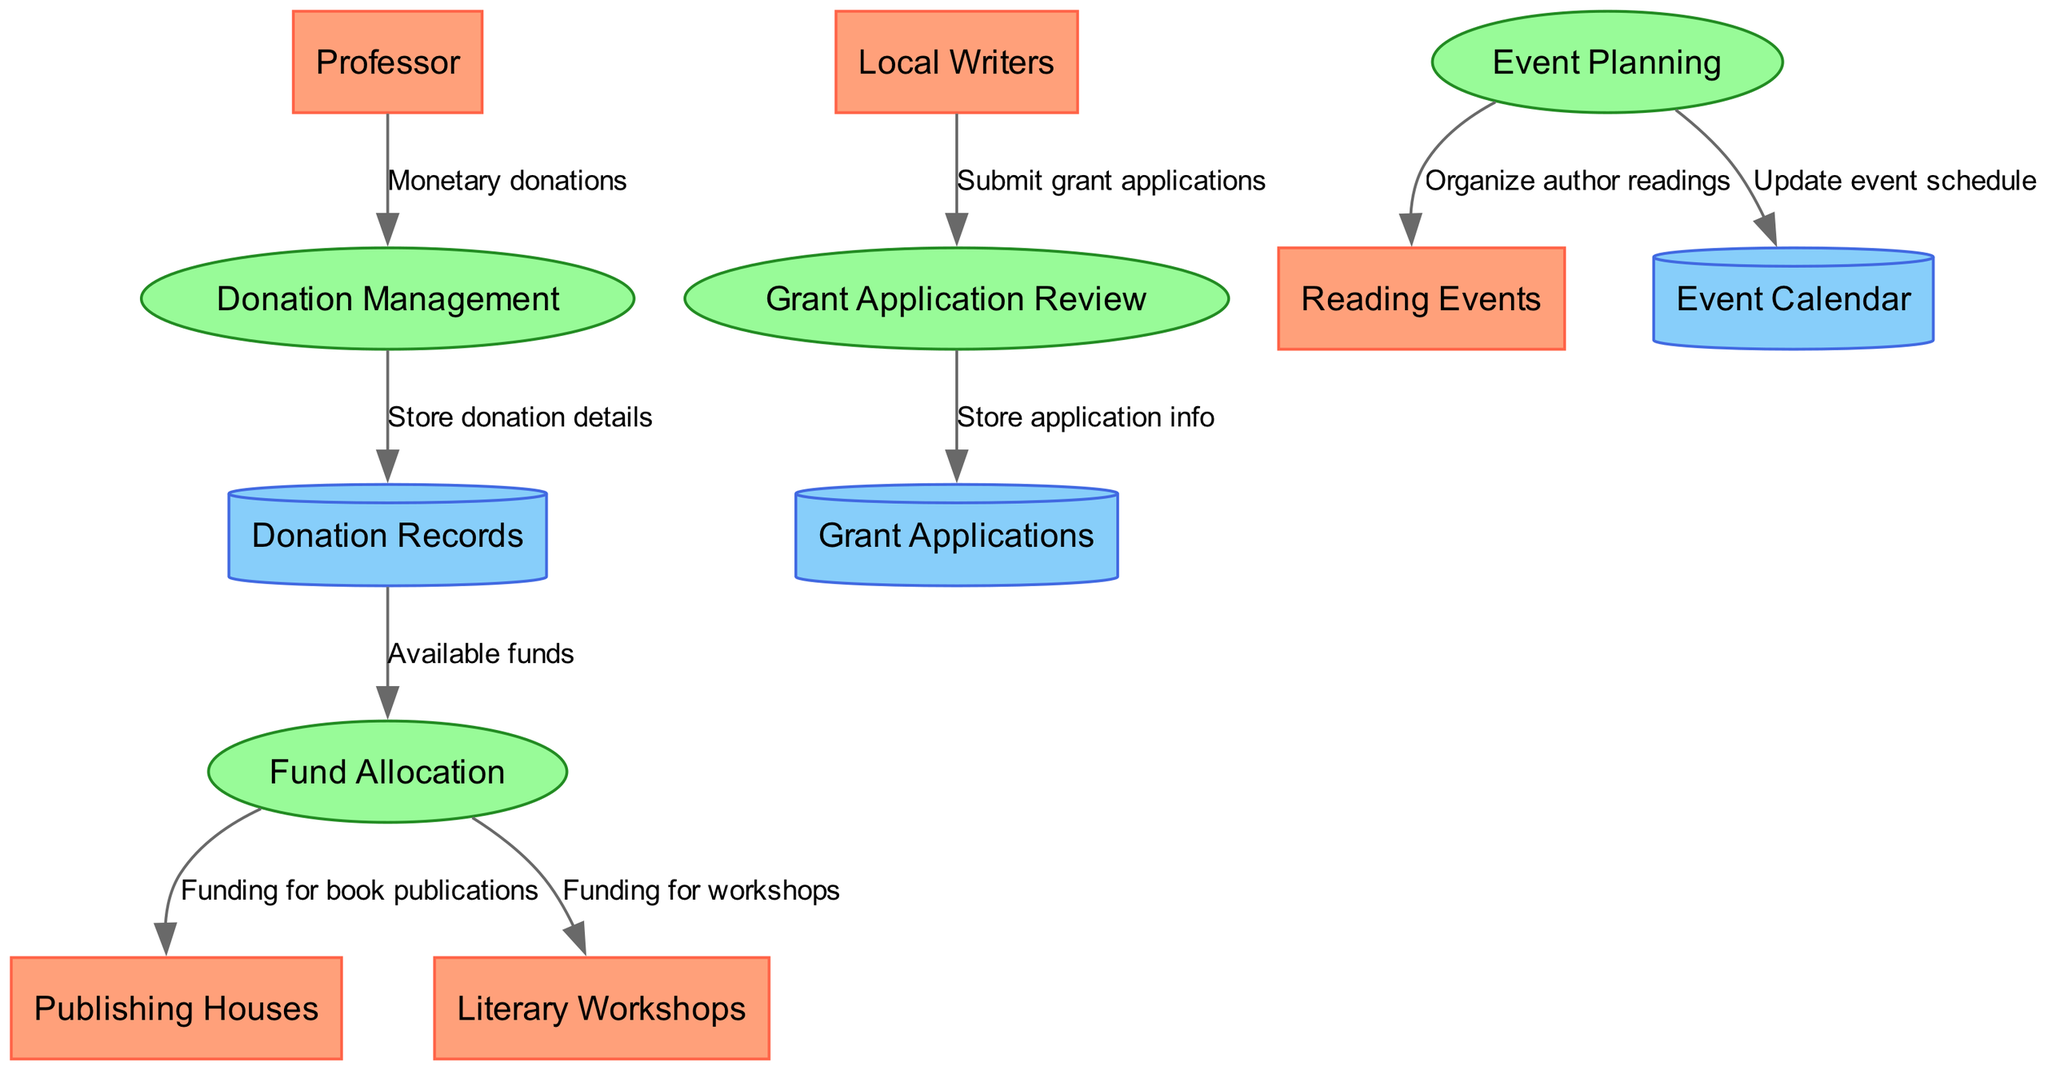What external entity initiates the donation process? The external entity that initiates the donation process, as shown in the diagram, is the "Professor". This is evident from the flow that starts from the "Professor" and goes to the "Donation Management" process, indicating that the professor is the source of monetary donations.
Answer: Professor How many processes are involved in fund allocation? In the diagram, there are three specific processes that are involved with fund allocation: "Donation Management", "Fund Allocation", and "Grant Application Review". Counting them gives us a total of three processes that are involved in managing and distributing the funds.
Answer: 3 What information does the "Donation Management" send to the "Donation Records"? The "Donation Management" process sends "Store donation details" to the "Donation Records". This is indicated in the flow from "Donation Management" to "Donation Records", indicating that donation details are stored as part of the record-keeping step.
Answer: Store donation details Which process is responsible for reviewing grant applications? The process that is responsible for reviewing grant applications is "Grant Application Review". This is clearly indicated in the diagram as the process that receives submissions from "Local Writers" in the form of grant applications.
Answer: Grant Application Review What are the two types of funding directed from "Fund Allocation"? The "Fund Allocation" process directs funding to "Publishing Houses" for book publications and to "Literary Workshops" for funding workshops. This dual pathway highlights the specific areas that receive financial support from the allocated funds.
Answer: Publishing Houses, Literary Workshops What entity receives updates about the organized events? The entity that receives updates about the organized events is the "Event Calendar". In the diagram, it shows the flow from "Event Planning" to "Event Calendar", indicating that updates regarding the event schedule are communicated to this entity.
Answer: Event Calendar How many external entities are connected to the data flow? There are five external entities as listed in the diagram: "Professor", "Local Writers", "Publishing Houses", "Literary Workshops", and "Reading Events". By counting these entities, we can confirm there are five total external entities involved.
Answer: 5 From which entity do local writers submit their grant applications? Local writers submit their grant applications from the "Local Writers" entity, as shown by the flow from "Local Writers" to "Grant Application Review" in the diagram. This indicates that the local writers are directly interacting with the grant application process.
Answer: Local Writers What is created by the "Event Planning" process for future activities? The "Event Planning" process creates "Organize author readings" for future activities, as shown by the flow leading from "Event Planning" to "Reading Events". This indicates that events are planned based on the activities organized through this process.
Answer: Organize author readings 